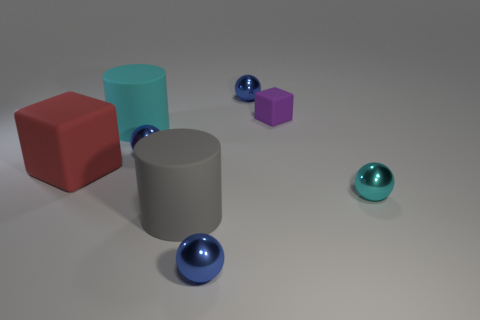How many blue spheres must be subtracted to get 1 blue spheres? 2 Subtract all tiny cyan balls. How many balls are left? 3 Subtract all cyan spheres. How many spheres are left? 3 Subtract 0 cyan cubes. How many objects are left? 8 Subtract all cubes. How many objects are left? 6 Subtract 1 cylinders. How many cylinders are left? 1 Subtract all gray cubes. Subtract all brown balls. How many cubes are left? 2 Subtract all green cylinders. How many cyan blocks are left? 0 Subtract all cyan metallic spheres. Subtract all small cyan metal balls. How many objects are left? 6 Add 6 big rubber blocks. How many big rubber blocks are left? 7 